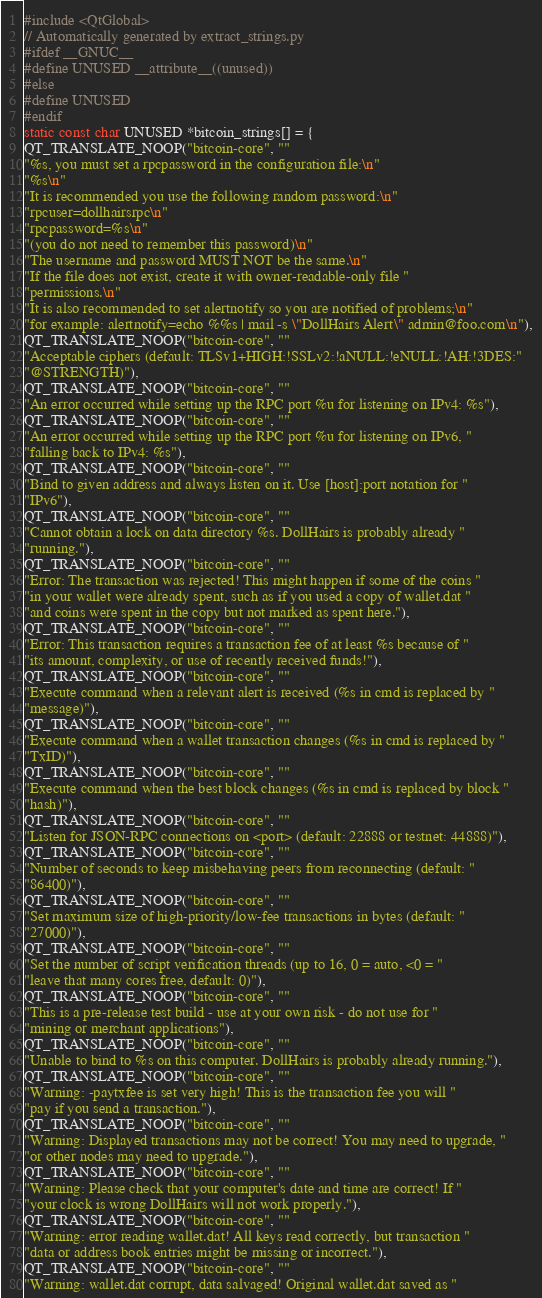<code> <loc_0><loc_0><loc_500><loc_500><_C++_>#include <QtGlobal>
// Automatically generated by extract_strings.py
#ifdef __GNUC__
#define UNUSED __attribute__((unused))
#else
#define UNUSED
#endif
static const char UNUSED *bitcoin_strings[] = {
QT_TRANSLATE_NOOP("bitcoin-core", ""
"%s, you must set a rpcpassword in the configuration file:\n"
"%s\n"
"It is recommended you use the following random password:\n"
"rpcuser=dollhairsrpc\n"
"rpcpassword=%s\n"
"(you do not need to remember this password)\n"
"The username and password MUST NOT be the same.\n"
"If the file does not exist, create it with owner-readable-only file "
"permissions.\n"
"It is also recommended to set alertnotify so you are notified of problems;\n"
"for example: alertnotify=echo %%s | mail -s \"DollHairs Alert\" admin@foo.com\n"),
QT_TRANSLATE_NOOP("bitcoin-core", ""
"Acceptable ciphers (default: TLSv1+HIGH:!SSLv2:!aNULL:!eNULL:!AH:!3DES:"
"@STRENGTH)"),
QT_TRANSLATE_NOOP("bitcoin-core", ""
"An error occurred while setting up the RPC port %u for listening on IPv4: %s"),
QT_TRANSLATE_NOOP("bitcoin-core", ""
"An error occurred while setting up the RPC port %u for listening on IPv6, "
"falling back to IPv4: %s"),
QT_TRANSLATE_NOOP("bitcoin-core", ""
"Bind to given address and always listen on it. Use [host]:port notation for "
"IPv6"),
QT_TRANSLATE_NOOP("bitcoin-core", ""
"Cannot obtain a lock on data directory %s. DollHairs is probably already "
"running."),
QT_TRANSLATE_NOOP("bitcoin-core", ""
"Error: The transaction was rejected! This might happen if some of the coins "
"in your wallet were already spent, such as if you used a copy of wallet.dat "
"and coins were spent in the copy but not marked as spent here."),
QT_TRANSLATE_NOOP("bitcoin-core", ""
"Error: This transaction requires a transaction fee of at least %s because of "
"its amount, complexity, or use of recently received funds!"),
QT_TRANSLATE_NOOP("bitcoin-core", ""
"Execute command when a relevant alert is received (%s in cmd is replaced by "
"message)"),
QT_TRANSLATE_NOOP("bitcoin-core", ""
"Execute command when a wallet transaction changes (%s in cmd is replaced by "
"TxID)"),
QT_TRANSLATE_NOOP("bitcoin-core", ""
"Execute command when the best block changes (%s in cmd is replaced by block "
"hash)"),
QT_TRANSLATE_NOOP("bitcoin-core", ""
"Listen for JSON-RPC connections on <port> (default: 22888 or testnet: 44888)"),
QT_TRANSLATE_NOOP("bitcoin-core", ""
"Number of seconds to keep misbehaving peers from reconnecting (default: "
"86400)"),
QT_TRANSLATE_NOOP("bitcoin-core", ""
"Set maximum size of high-priority/low-fee transactions in bytes (default: "
"27000)"),
QT_TRANSLATE_NOOP("bitcoin-core", ""
"Set the number of script verification threads (up to 16, 0 = auto, <0 = "
"leave that many cores free, default: 0)"),
QT_TRANSLATE_NOOP("bitcoin-core", ""
"This is a pre-release test build - use at your own risk - do not use for "
"mining or merchant applications"),
QT_TRANSLATE_NOOP("bitcoin-core", ""
"Unable to bind to %s on this computer. DollHairs is probably already running."),
QT_TRANSLATE_NOOP("bitcoin-core", ""
"Warning: -paytxfee is set very high! This is the transaction fee you will "
"pay if you send a transaction."),
QT_TRANSLATE_NOOP("bitcoin-core", ""
"Warning: Displayed transactions may not be correct! You may need to upgrade, "
"or other nodes may need to upgrade."),
QT_TRANSLATE_NOOP("bitcoin-core", ""
"Warning: Please check that your computer's date and time are correct! If "
"your clock is wrong DollHairs will not work properly."),
QT_TRANSLATE_NOOP("bitcoin-core", ""
"Warning: error reading wallet.dat! All keys read correctly, but transaction "
"data or address book entries might be missing or incorrect."),
QT_TRANSLATE_NOOP("bitcoin-core", ""
"Warning: wallet.dat corrupt, data salvaged! Original wallet.dat saved as "</code> 